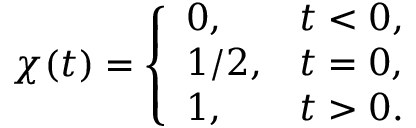<formula> <loc_0><loc_0><loc_500><loc_500>\chi ( t ) = \left \{ \begin{array} { l l } { 0 , } & { t < 0 , } \\ { 1 / 2 , } & { t = 0 , } \\ { 1 , } & { t > 0 . } \end{array}</formula> 